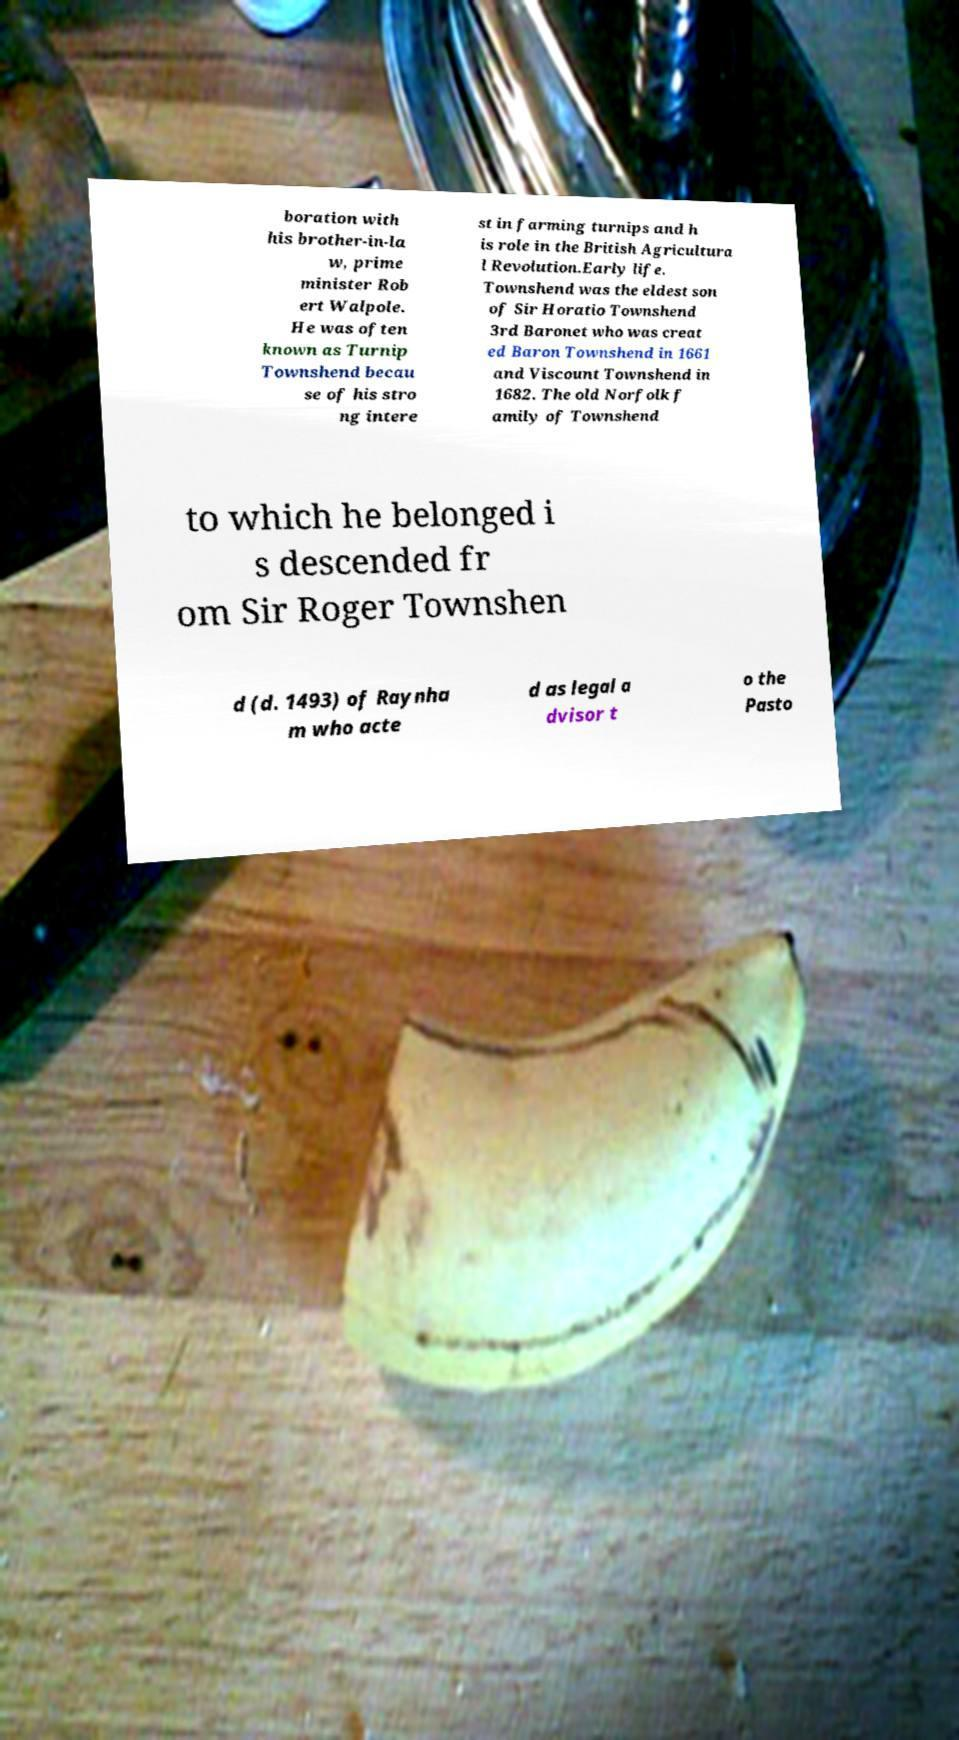Could you assist in decoding the text presented in this image and type it out clearly? boration with his brother-in-la w, prime minister Rob ert Walpole. He was often known as Turnip Townshend becau se of his stro ng intere st in farming turnips and h is role in the British Agricultura l Revolution.Early life. Townshend was the eldest son of Sir Horatio Townshend 3rd Baronet who was creat ed Baron Townshend in 1661 and Viscount Townshend in 1682. The old Norfolk f amily of Townshend to which he belonged i s descended fr om Sir Roger Townshen d (d. 1493) of Raynha m who acte d as legal a dvisor t o the Pasto 